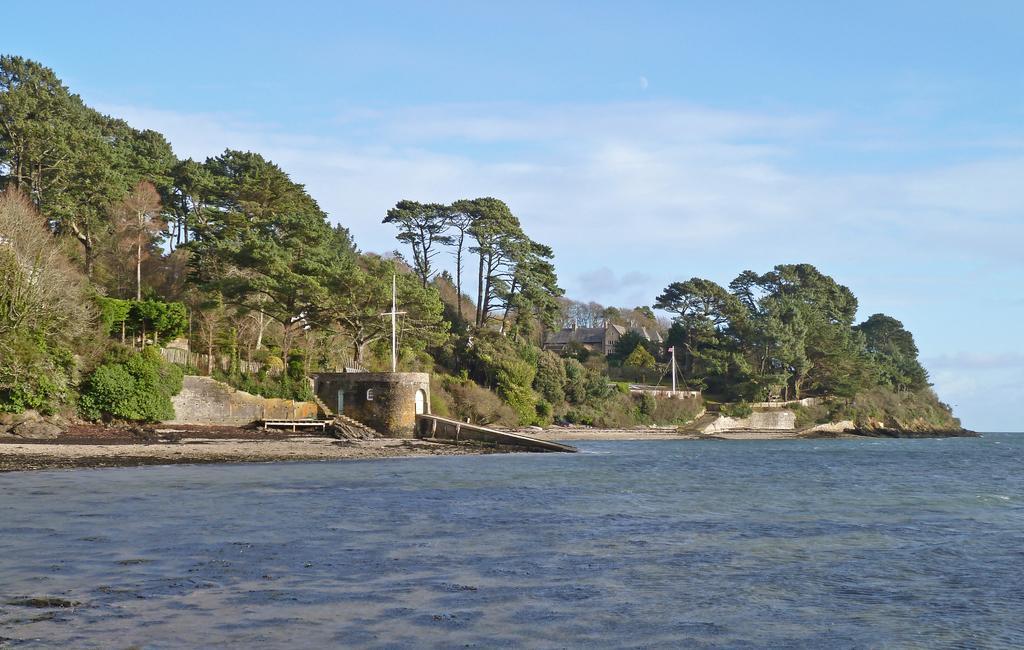Could you give a brief overview of what you see in this image? There is water. In the background, there is wall, there are trees, a building, poles and plants on the ground and there are clouds in the blue sky. 